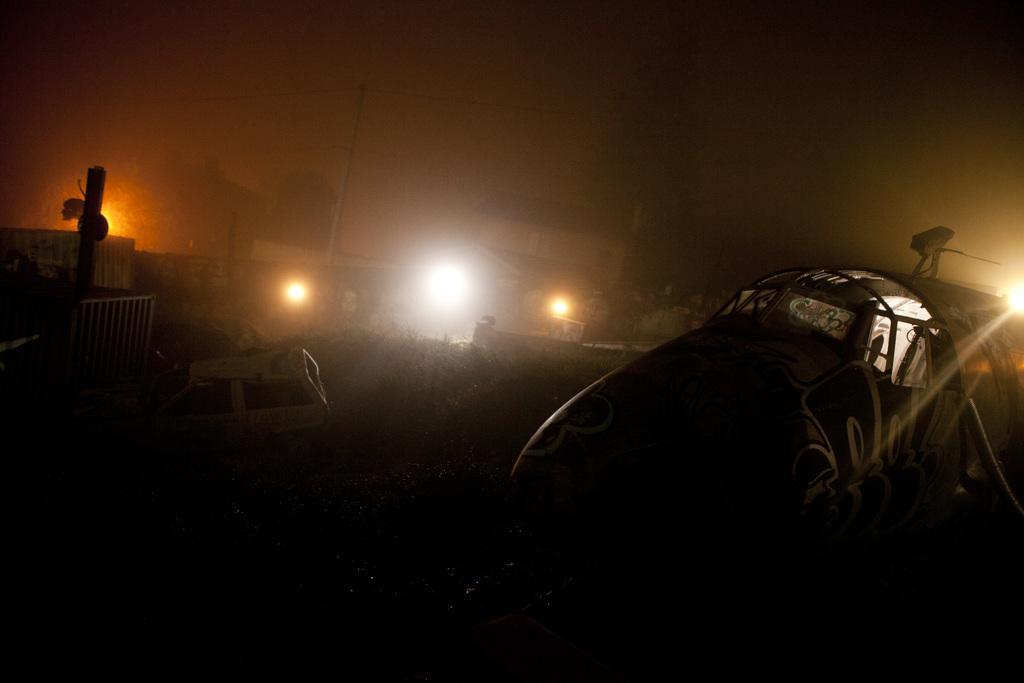In one or two sentences, can you explain what this image depicts? In this image, we can see a few vehicles, plants, house, pillars, lights, wall. 